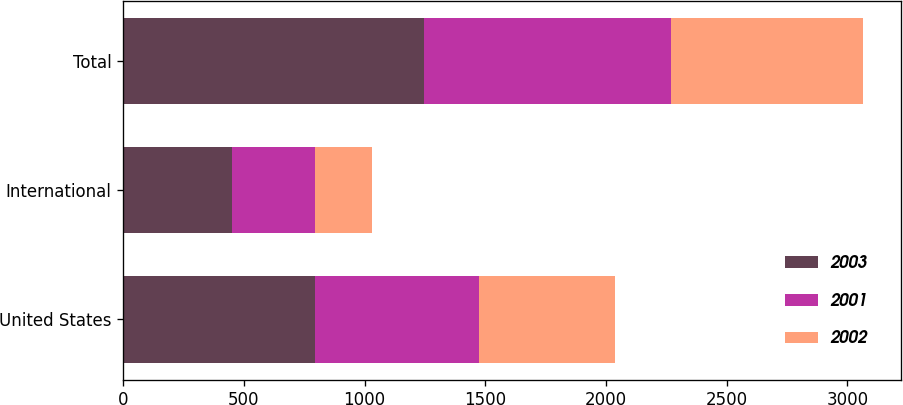Convert chart to OTSL. <chart><loc_0><loc_0><loc_500><loc_500><stacked_bar_chart><ecel><fcel>United States<fcel>International<fcel>Total<nl><fcel>2003<fcel>795.3<fcel>451.3<fcel>1246.6<nl><fcel>2001<fcel>680.8<fcel>342.5<fcel>1023.3<nl><fcel>2002<fcel>560.7<fcel>236<fcel>796.7<nl></chart> 